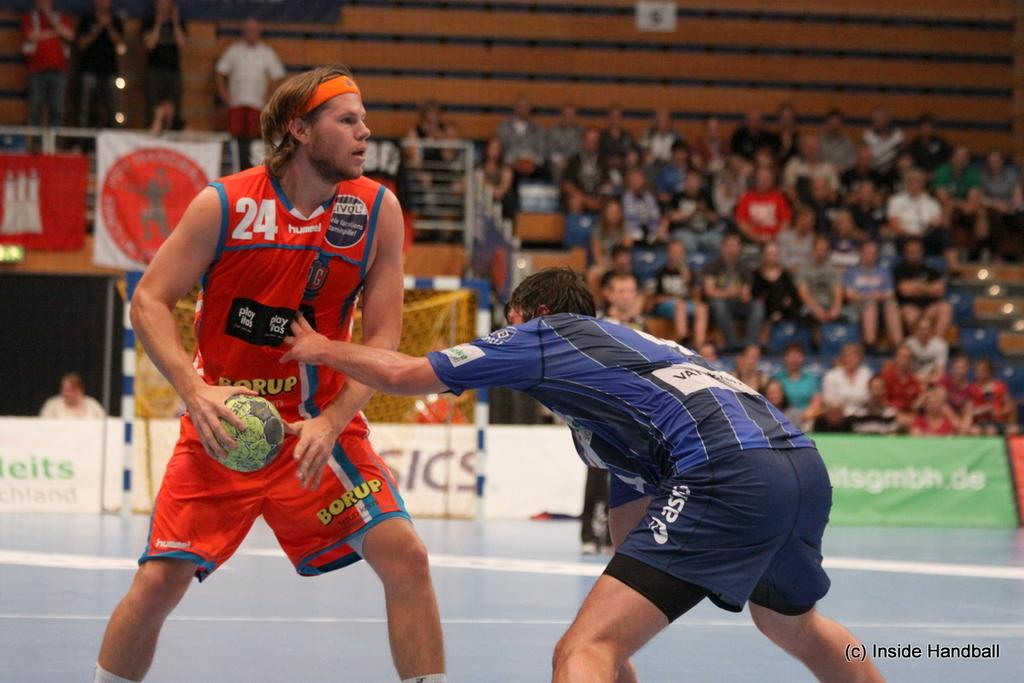<image>
Create a compact narrative representing the image presented. A photo of two players in active play is titled (c) Inside Handball. 